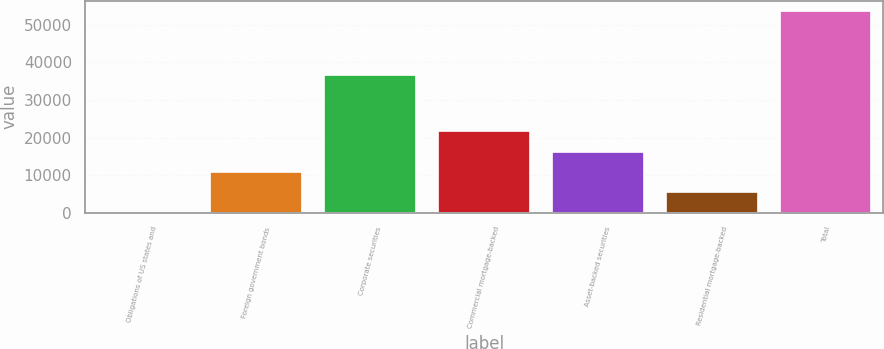Convert chart to OTSL. <chart><loc_0><loc_0><loc_500><loc_500><bar_chart><fcel>Obligations of US states and<fcel>Foreign government bonds<fcel>Corporate securities<fcel>Commercial mortgage-backed<fcel>Asset-backed securities<fcel>Residential mortgage-backed<fcel>Total<nl><fcel>299<fcel>10980.8<fcel>36549<fcel>21662.6<fcel>16321.7<fcel>5639.9<fcel>53708<nl></chart> 